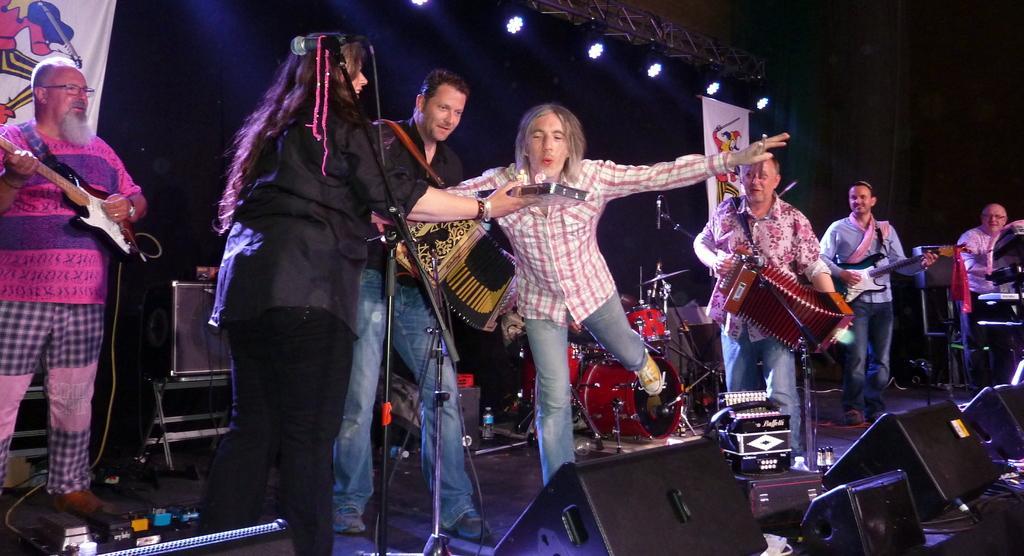Could you give a brief overview of what you see in this image? In this image we can see some people standing on the floor playing different musical instruments. We can also see a speaker, drums, fedge lights, bottles and a posture on the stage. On the backside we can see some ceiling lights, curtain and a posture. 